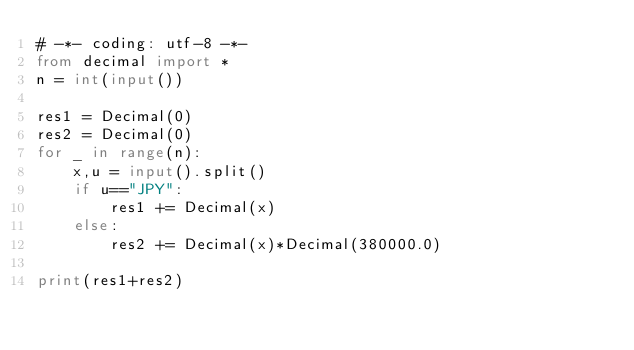Convert code to text. <code><loc_0><loc_0><loc_500><loc_500><_Python_># -*- coding: utf-8 -*-
from decimal import *
n = int(input())

res1 = Decimal(0)
res2 = Decimal(0)
for _ in range(n):
    x,u = input().split()
    if u=="JPY":
        res1 += Decimal(x)
    else:
        res2 += Decimal(x)*Decimal(380000.0)

print(res1+res2)
</code> 